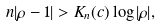<formula> <loc_0><loc_0><loc_500><loc_500>n | \rho - 1 | > K _ { n } ( c ) \log | \rho | ,</formula> 